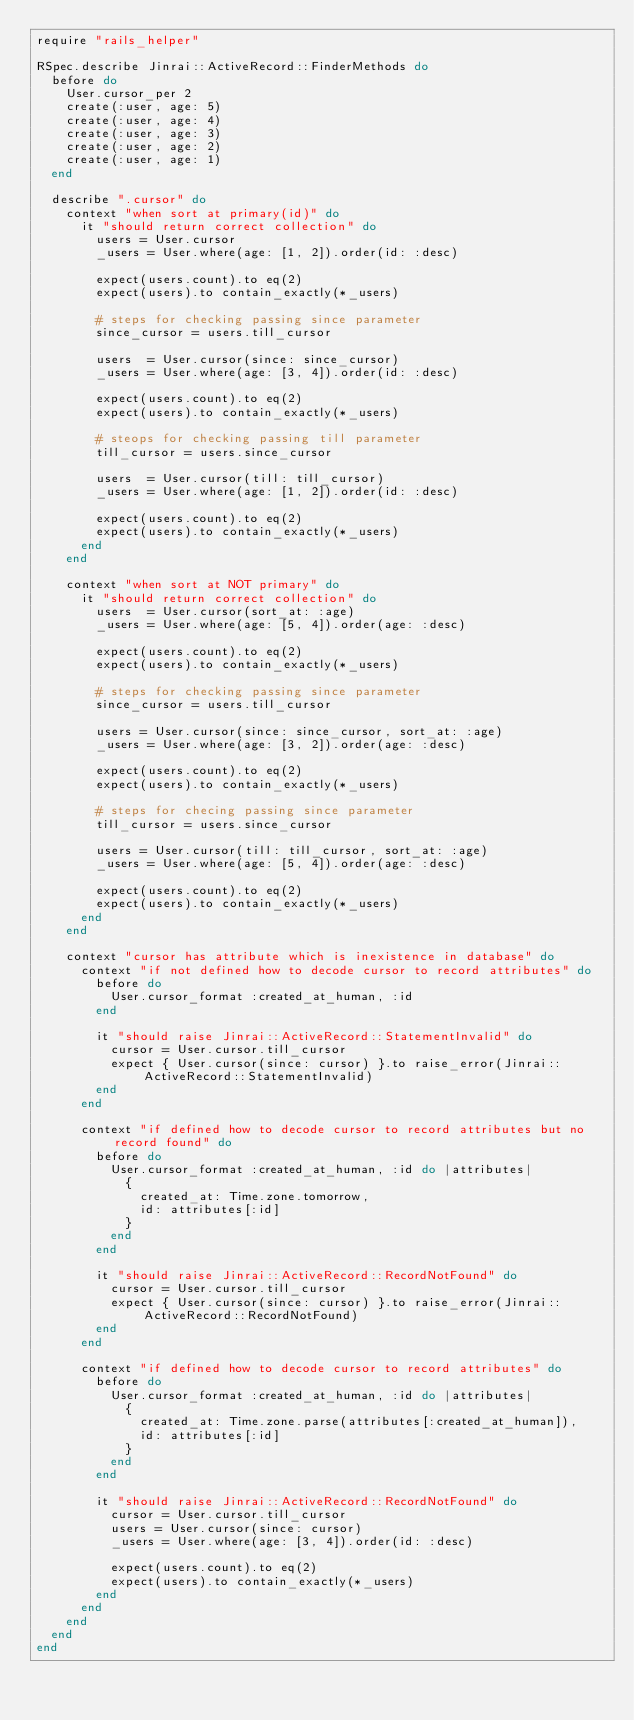<code> <loc_0><loc_0><loc_500><loc_500><_Ruby_>require "rails_helper"

RSpec.describe Jinrai::ActiveRecord::FinderMethods do
  before do
    User.cursor_per 2
    create(:user, age: 5)
    create(:user, age: 4)
    create(:user, age: 3)
    create(:user, age: 2)
    create(:user, age: 1)
  end

  describe ".cursor" do
    context "when sort at primary(id)" do
      it "should return correct collection" do
        users = User.cursor
        _users = User.where(age: [1, 2]).order(id: :desc)

        expect(users.count).to eq(2)
        expect(users).to contain_exactly(*_users)

        # steps for checking passing since parameter
        since_cursor = users.till_cursor

        users  = User.cursor(since: since_cursor)
        _users = User.where(age: [3, 4]).order(id: :desc)

        expect(users.count).to eq(2)
        expect(users).to contain_exactly(*_users)

        # steops for checking passing till parameter
        till_cursor = users.since_cursor

        users  = User.cursor(till: till_cursor)
        _users = User.where(age: [1, 2]).order(id: :desc)

        expect(users.count).to eq(2)
        expect(users).to contain_exactly(*_users)
      end
    end

    context "when sort at NOT primary" do
      it "should return correct collection" do
        users  = User.cursor(sort_at: :age)
        _users = User.where(age: [5, 4]).order(age: :desc)

        expect(users.count).to eq(2)
        expect(users).to contain_exactly(*_users)

        # steps for checking passing since parameter
        since_cursor = users.till_cursor

        users = User.cursor(since: since_cursor, sort_at: :age)
        _users = User.where(age: [3, 2]).order(age: :desc)

        expect(users.count).to eq(2)
        expect(users).to contain_exactly(*_users)

        # steps for checing passing since parameter
        till_cursor = users.since_cursor

        users = User.cursor(till: till_cursor, sort_at: :age)
        _users = User.where(age: [5, 4]).order(age: :desc)

        expect(users.count).to eq(2)
        expect(users).to contain_exactly(*_users)
      end
    end

    context "cursor has attribute which is inexistence in database" do
      context "if not defined how to decode cursor to record attributes" do
        before do
          User.cursor_format :created_at_human, :id
        end

        it "should raise Jinrai::ActiveRecord::StatementInvalid" do
          cursor = User.cursor.till_cursor
          expect { User.cursor(since: cursor) }.to raise_error(Jinrai::ActiveRecord::StatementInvalid)
        end
      end

      context "if defined how to decode cursor to record attributes but no record found" do
        before do
          User.cursor_format :created_at_human, :id do |attributes|
            {
              created_at: Time.zone.tomorrow,
              id: attributes[:id]
            }
          end
        end

        it "should raise Jinrai::ActiveRecord::RecordNotFound" do
          cursor = User.cursor.till_cursor
          expect { User.cursor(since: cursor) }.to raise_error(Jinrai::ActiveRecord::RecordNotFound)
        end
      end

      context "if defined how to decode cursor to record attributes" do
        before do
          User.cursor_format :created_at_human, :id do |attributes|
            {
              created_at: Time.zone.parse(attributes[:created_at_human]),
              id: attributes[:id]
            }
          end
        end

        it "should raise Jinrai::ActiveRecord::RecordNotFound" do
          cursor = User.cursor.till_cursor
          users = User.cursor(since: cursor)
          _users = User.where(age: [3, 4]).order(id: :desc)

          expect(users.count).to eq(2)
          expect(users).to contain_exactly(*_users)
        end
      end
    end
  end
end
</code> 